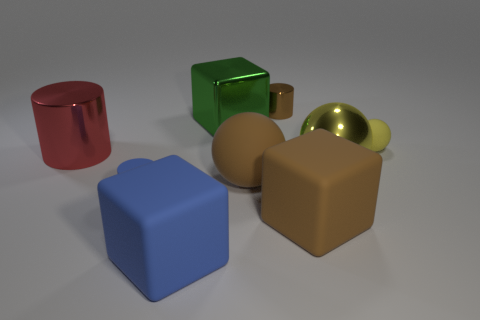What size is the brown matte thing that is behind the tiny matte object that is left of the tiny cylinder that is to the right of the big green object?
Make the answer very short. Large. Are there any large blue rubber objects to the right of the large metallic cube?
Offer a very short reply. No. The big object that is the same color as the small rubber cylinder is what shape?
Provide a short and direct response. Cube. What number of objects are either brown rubber objects that are behind the big brown block or big yellow shiny balls?
Provide a short and direct response. 2. There is a sphere that is made of the same material as the big green object; what size is it?
Your answer should be compact. Large. There is a brown matte cube; is its size the same as the matte ball to the right of the brown cylinder?
Make the answer very short. No. There is a cylinder that is both to the left of the green shiny object and behind the matte cylinder; what color is it?
Give a very brief answer. Red. How many objects are yellow things in front of the yellow rubber sphere or metal things to the right of the red shiny cylinder?
Give a very brief answer. 3. What color is the matte ball on the left side of the large yellow metal ball behind the tiny cylinder in front of the big yellow sphere?
Keep it short and to the point. Brown. Is there a blue rubber thing of the same shape as the green object?
Offer a very short reply. Yes. 